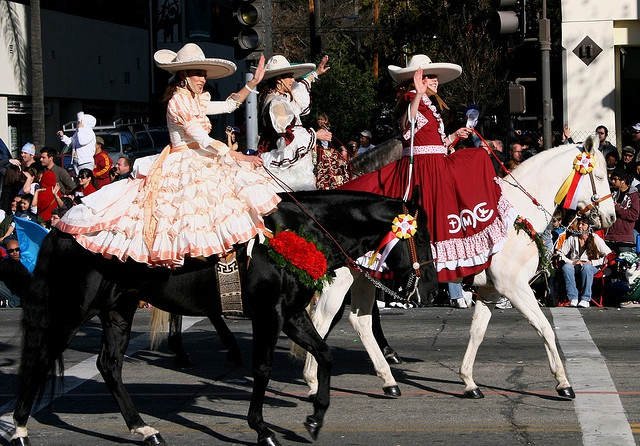Describe the objects in this image and their specific colors. I can see horse in gray, black, brown, and maroon tones, people in gray, lightgray, lightpink, tan, and brown tones, horse in gray, lightgray, black, and darkgray tones, people in gray, brown, lavender, maroon, and black tones, and people in gray, black, maroon, and lightgray tones in this image. 